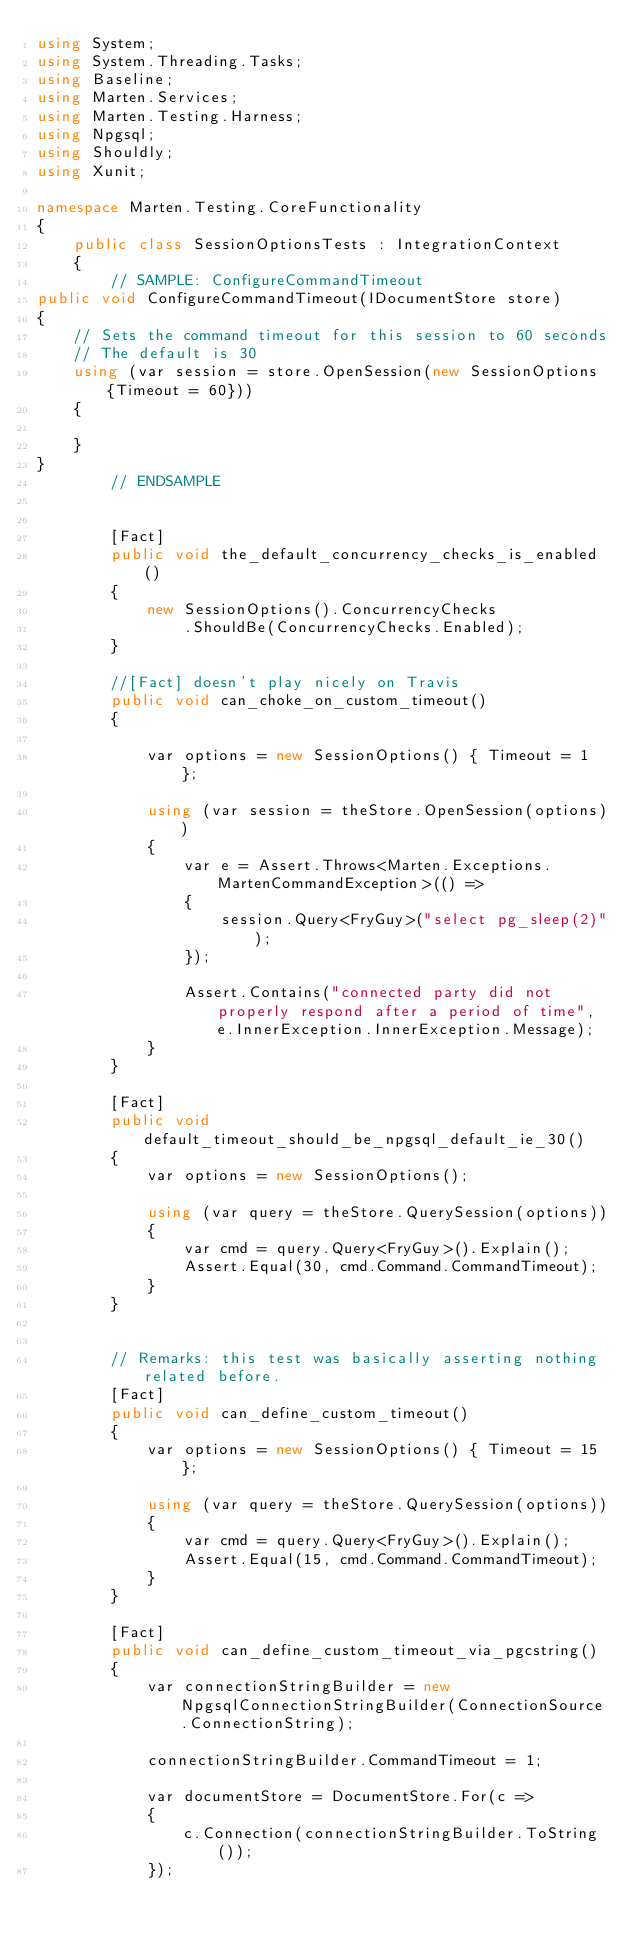<code> <loc_0><loc_0><loc_500><loc_500><_C#_>using System;
using System.Threading.Tasks;
using Baseline;
using Marten.Services;
using Marten.Testing.Harness;
using Npgsql;
using Shouldly;
using Xunit;

namespace Marten.Testing.CoreFunctionality
{
    public class SessionOptionsTests : IntegrationContext
    {
        // SAMPLE: ConfigureCommandTimeout
public void ConfigureCommandTimeout(IDocumentStore store)
{
    // Sets the command timeout for this session to 60 seconds
    // The default is 30
    using (var session = store.OpenSession(new SessionOptions {Timeout = 60}))
    {

    }
}
        // ENDSAMPLE


        [Fact]
        public void the_default_concurrency_checks_is_enabled()
        {
            new SessionOptions().ConcurrencyChecks
                .ShouldBe(ConcurrencyChecks.Enabled);
        }

        //[Fact] doesn't play nicely on Travis
        public void can_choke_on_custom_timeout()
        {

            var options = new SessionOptions() { Timeout = 1 };

            using (var session = theStore.OpenSession(options))
            {
                var e = Assert.Throws<Marten.Exceptions.MartenCommandException>(() =>
                {
                    session.Query<FryGuy>("select pg_sleep(2)");
                });

                Assert.Contains("connected party did not properly respond after a period of time", e.InnerException.InnerException.Message);
            }
        }

        [Fact]
        public void default_timeout_should_be_npgsql_default_ie_30()
        {
            var options = new SessionOptions();

            using (var query = theStore.QuerySession(options))
            {
                var cmd = query.Query<FryGuy>().Explain();
                Assert.Equal(30, cmd.Command.CommandTimeout);
            }
        }


        // Remarks: this test was basically asserting nothing related before.
        [Fact]
        public void can_define_custom_timeout()
        {
            var options = new SessionOptions() { Timeout = 15 };

            using (var query = theStore.QuerySession(options))
            {
                var cmd = query.Query<FryGuy>().Explain();
                Assert.Equal(15, cmd.Command.CommandTimeout);
            }
        }

        [Fact]
        public void can_define_custom_timeout_via_pgcstring()
        {
            var connectionStringBuilder = new NpgsqlConnectionStringBuilder(ConnectionSource.ConnectionString);

            connectionStringBuilder.CommandTimeout = 1;

            var documentStore = DocumentStore.For(c =>
            {
                c.Connection(connectionStringBuilder.ToString());
            });
</code> 